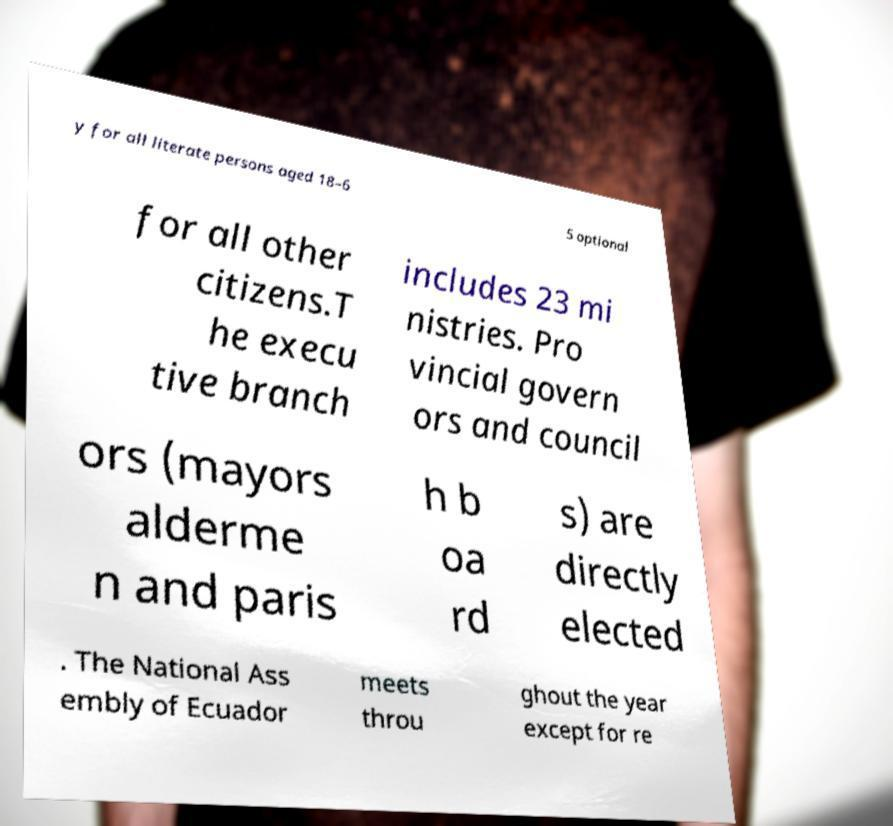I need the written content from this picture converted into text. Can you do that? y for all literate persons aged 18–6 5 optional for all other citizens.T he execu tive branch includes 23 mi nistries. Pro vincial govern ors and council ors (mayors alderme n and paris h b oa rd s) are directly elected . The National Ass embly of Ecuador meets throu ghout the year except for re 